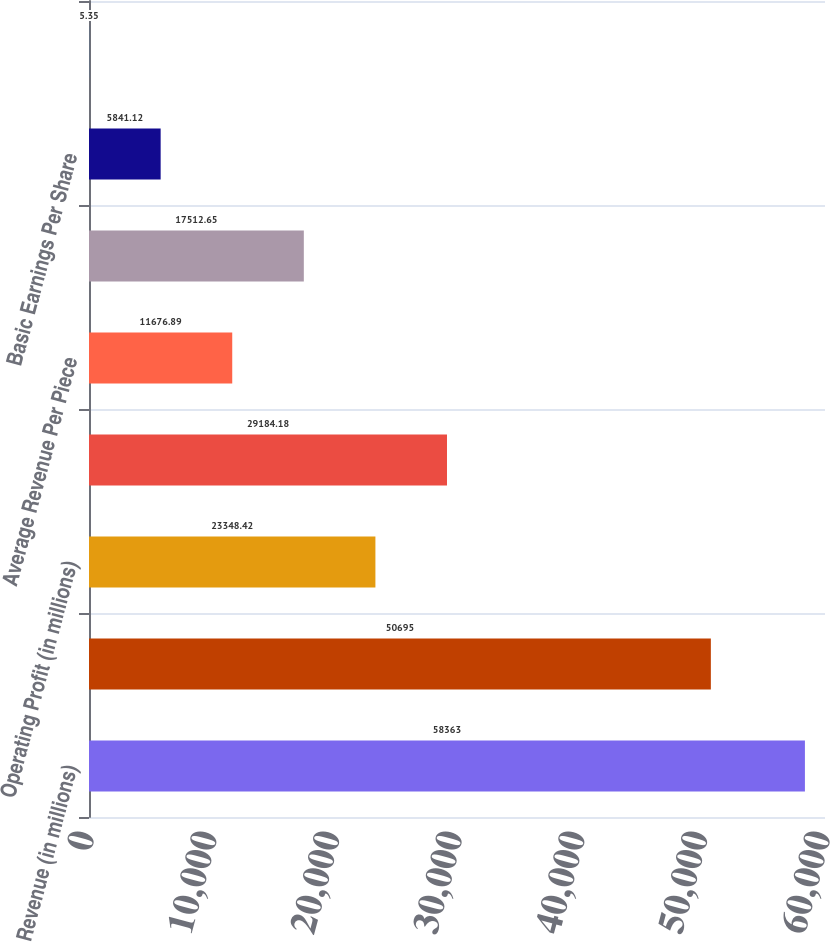<chart> <loc_0><loc_0><loc_500><loc_500><bar_chart><fcel>Revenue (in millions)<fcel>Operating Expenses (in<fcel>Operating Profit (in millions)<fcel>Average Daily Package Volume<fcel>Average Revenue Per Piece<fcel>Net Income (in millions)<fcel>Basic Earnings Per Share<fcel>Diluted Earnings Per Share<nl><fcel>58363<fcel>50695<fcel>23348.4<fcel>29184.2<fcel>11676.9<fcel>17512.7<fcel>5841.12<fcel>5.35<nl></chart> 